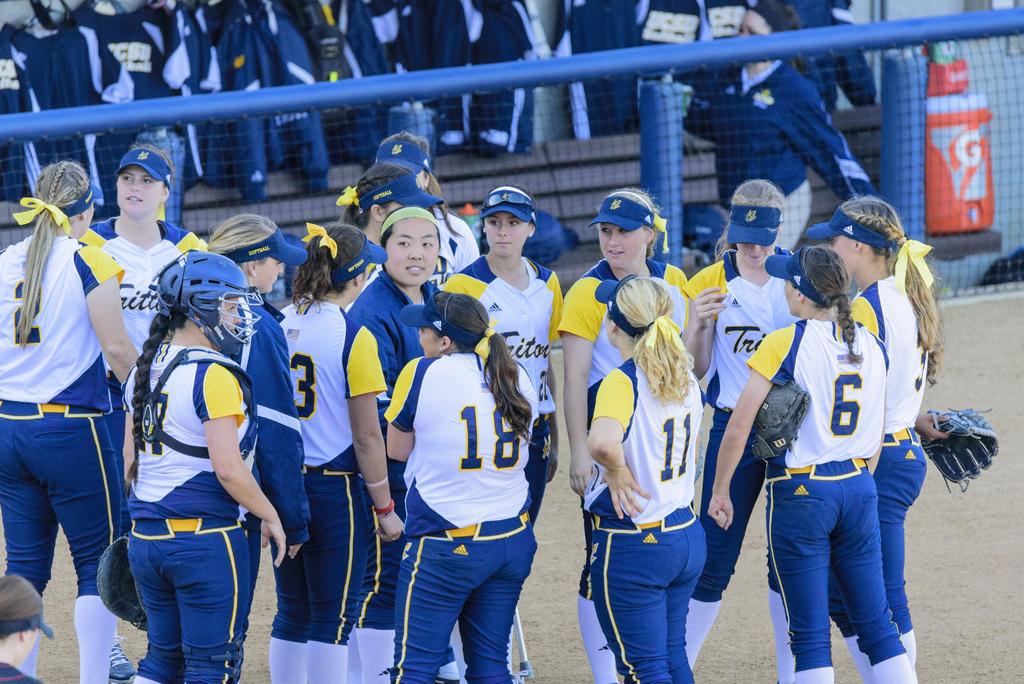What number is the blonde girl in the center?
Offer a very short reply. 11. What is the number of the girl on the far left with a long ponytail?
Offer a very short reply. 2. 